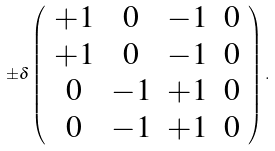<formula> <loc_0><loc_0><loc_500><loc_500>\pm \delta \left ( \begin{array} { c c c c } + 1 & 0 & - 1 & 0 \\ + 1 & 0 & - 1 & 0 \\ 0 & - 1 & + 1 & 0 \\ 0 & - 1 & + 1 & 0 \end{array} \right ) .</formula> 